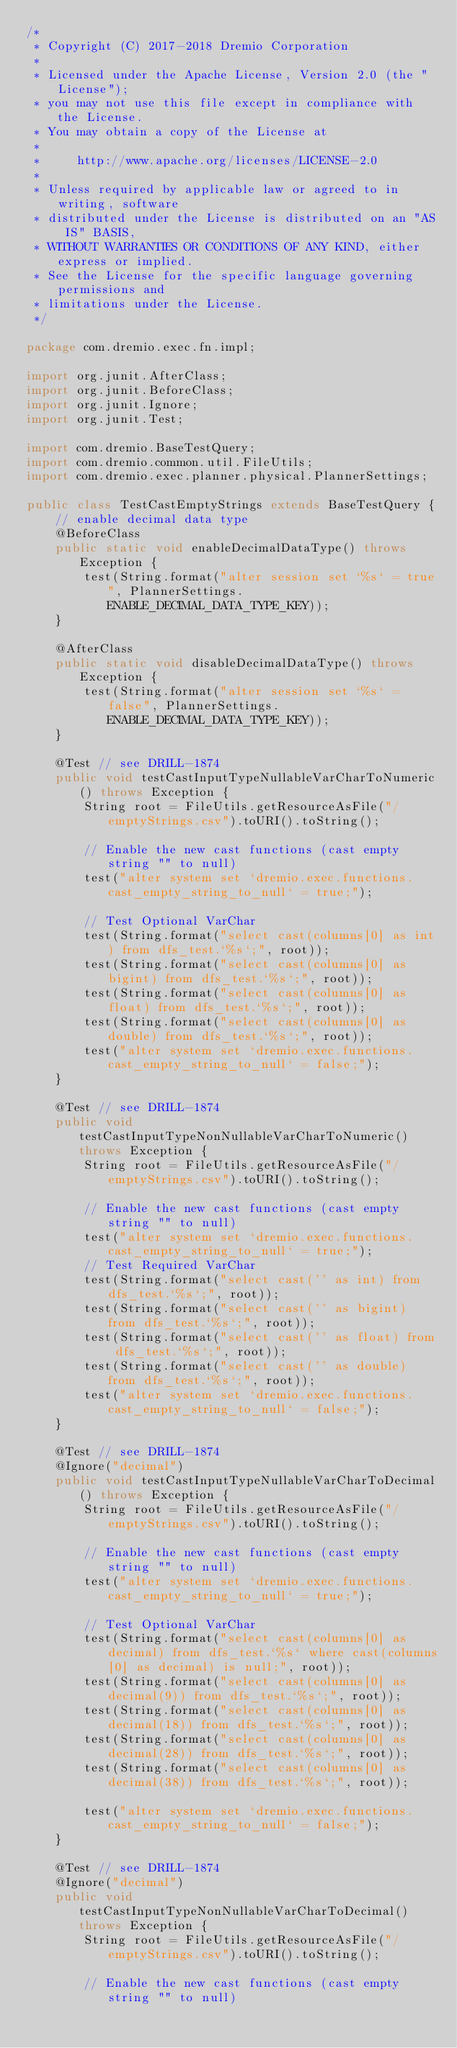Convert code to text. <code><loc_0><loc_0><loc_500><loc_500><_Java_>/*
 * Copyright (C) 2017-2018 Dremio Corporation
 *
 * Licensed under the Apache License, Version 2.0 (the "License");
 * you may not use this file except in compliance with the License.
 * You may obtain a copy of the License at
 *
 *     http://www.apache.org/licenses/LICENSE-2.0
 *
 * Unless required by applicable law or agreed to in writing, software
 * distributed under the License is distributed on an "AS IS" BASIS,
 * WITHOUT WARRANTIES OR CONDITIONS OF ANY KIND, either express or implied.
 * See the License for the specific language governing permissions and
 * limitations under the License.
 */

package com.dremio.exec.fn.impl;

import org.junit.AfterClass;
import org.junit.BeforeClass;
import org.junit.Ignore;
import org.junit.Test;

import com.dremio.BaseTestQuery;
import com.dremio.common.util.FileUtils;
import com.dremio.exec.planner.physical.PlannerSettings;

public class TestCastEmptyStrings extends BaseTestQuery {
    // enable decimal data type
    @BeforeClass
    public static void enableDecimalDataType() throws Exception {
        test(String.format("alter session set `%s` = true", PlannerSettings.ENABLE_DECIMAL_DATA_TYPE_KEY));
    }

    @AfterClass
    public static void disableDecimalDataType() throws Exception {
        test(String.format("alter session set `%s` = false", PlannerSettings.ENABLE_DECIMAL_DATA_TYPE_KEY));
    }

    @Test // see DRILL-1874
    public void testCastInputTypeNullableVarCharToNumeric() throws Exception {
        String root = FileUtils.getResourceAsFile("/emptyStrings.csv").toURI().toString();

        // Enable the new cast functions (cast empty string "" to null)
        test("alter system set `dremio.exec.functions.cast_empty_string_to_null` = true;");

        // Test Optional VarChar
        test(String.format("select cast(columns[0] as int) from dfs_test.`%s`;", root));
        test(String.format("select cast(columns[0] as bigint) from dfs_test.`%s`;", root));
        test(String.format("select cast(columns[0] as float) from dfs_test.`%s`;", root));
        test(String.format("select cast(columns[0] as double) from dfs_test.`%s`;", root));
        test("alter system set `dremio.exec.functions.cast_empty_string_to_null` = false;");
    }

    @Test // see DRILL-1874
    public void testCastInputTypeNonNullableVarCharToNumeric() throws Exception {
        String root = FileUtils.getResourceAsFile("/emptyStrings.csv").toURI().toString();

        // Enable the new cast functions (cast empty string "" to null)
        test("alter system set `dremio.exec.functions.cast_empty_string_to_null` = true;");
        // Test Required VarChar
        test(String.format("select cast('' as int) from dfs_test.`%s`;", root));
        test(String.format("select cast('' as bigint) from dfs_test.`%s`;", root));
        test(String.format("select cast('' as float) from dfs_test.`%s`;", root));
        test(String.format("select cast('' as double) from dfs_test.`%s`;", root));
        test("alter system set `dremio.exec.functions.cast_empty_string_to_null` = false;");
    }

    @Test // see DRILL-1874
    @Ignore("decimal")
    public void testCastInputTypeNullableVarCharToDecimal() throws Exception {
        String root = FileUtils.getResourceAsFile("/emptyStrings.csv").toURI().toString();

        // Enable the new cast functions (cast empty string "" to null)
        test("alter system set `dremio.exec.functions.cast_empty_string_to_null` = true;");

        // Test Optional VarChar
        test(String.format("select cast(columns[0] as decimal) from dfs_test.`%s` where cast(columns[0] as decimal) is null;", root));
        test(String.format("select cast(columns[0] as decimal(9)) from dfs_test.`%s`;", root));
        test(String.format("select cast(columns[0] as decimal(18)) from dfs_test.`%s`;", root));
        test(String.format("select cast(columns[0] as decimal(28)) from dfs_test.`%s`;", root));
        test(String.format("select cast(columns[0] as decimal(38)) from dfs_test.`%s`;", root));

        test("alter system set `dremio.exec.functions.cast_empty_string_to_null` = false;");
    }

    @Test // see DRILL-1874
    @Ignore("decimal")
    public void testCastInputTypeNonNullableVarCharToDecimal() throws Exception {
        String root = FileUtils.getResourceAsFile("/emptyStrings.csv").toURI().toString();

        // Enable the new cast functions (cast empty string "" to null)</code> 